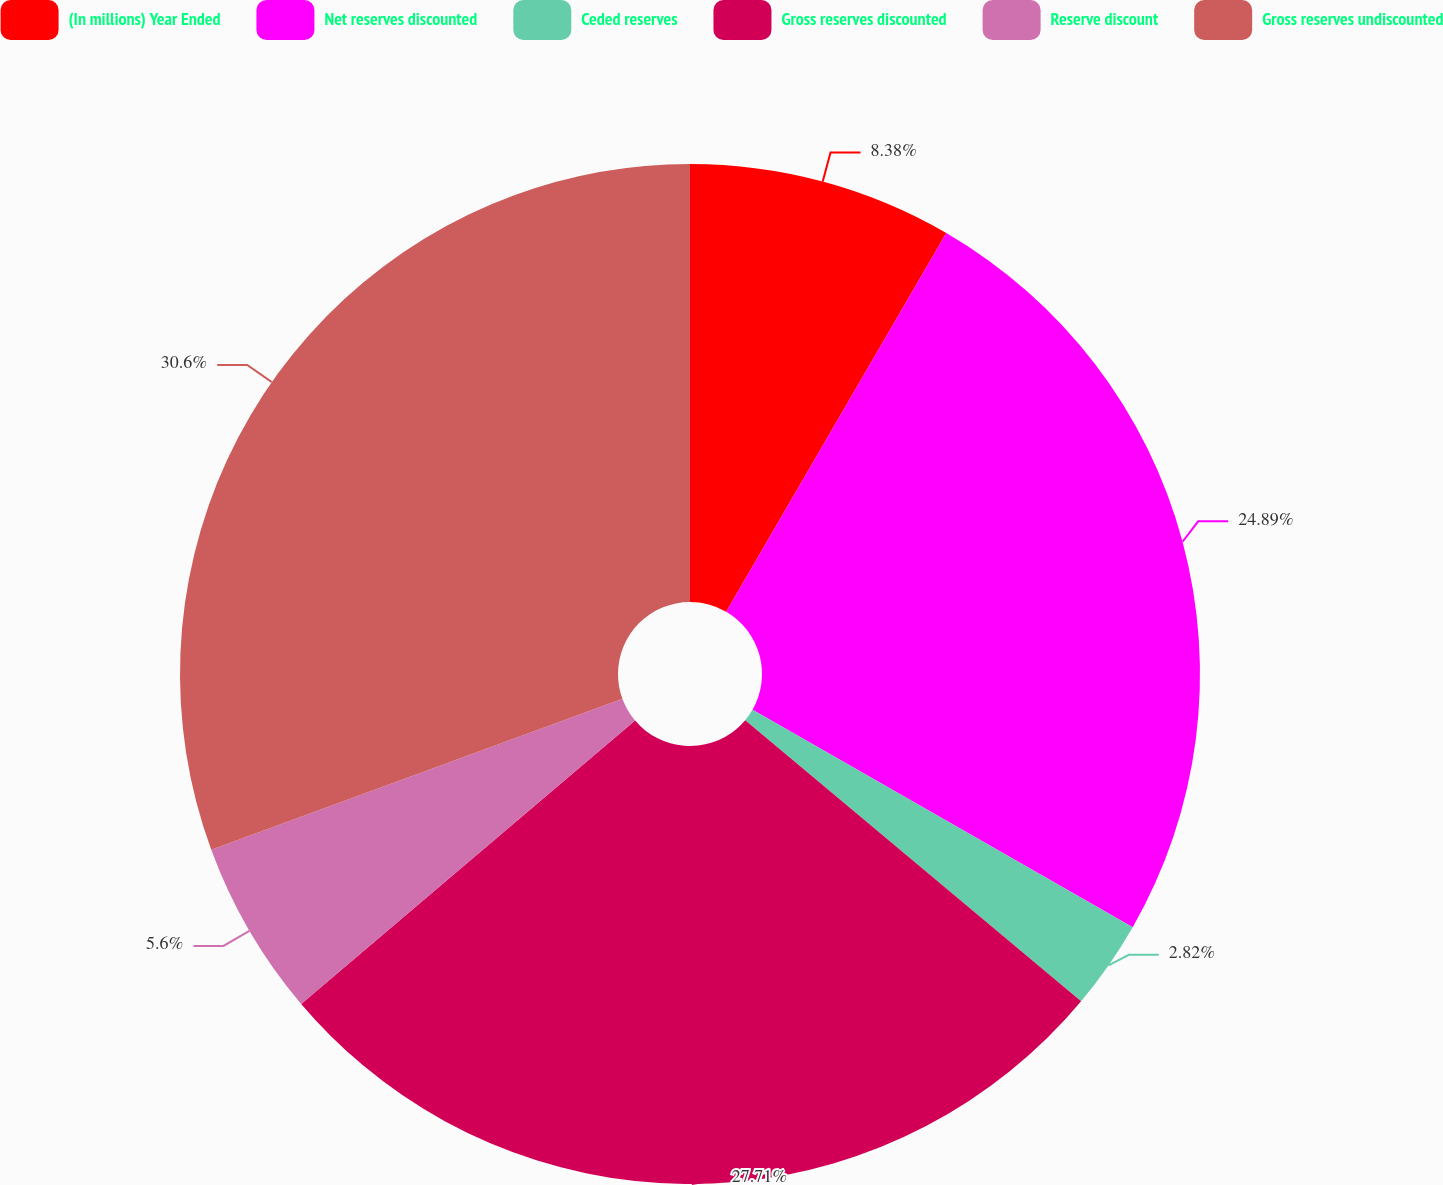Convert chart to OTSL. <chart><loc_0><loc_0><loc_500><loc_500><pie_chart><fcel>(In millions) Year Ended<fcel>Net reserves discounted<fcel>Ceded reserves<fcel>Gross reserves discounted<fcel>Reserve discount<fcel>Gross reserves undiscounted<nl><fcel>8.38%<fcel>24.89%<fcel>2.82%<fcel>27.71%<fcel>5.6%<fcel>30.6%<nl></chart> 